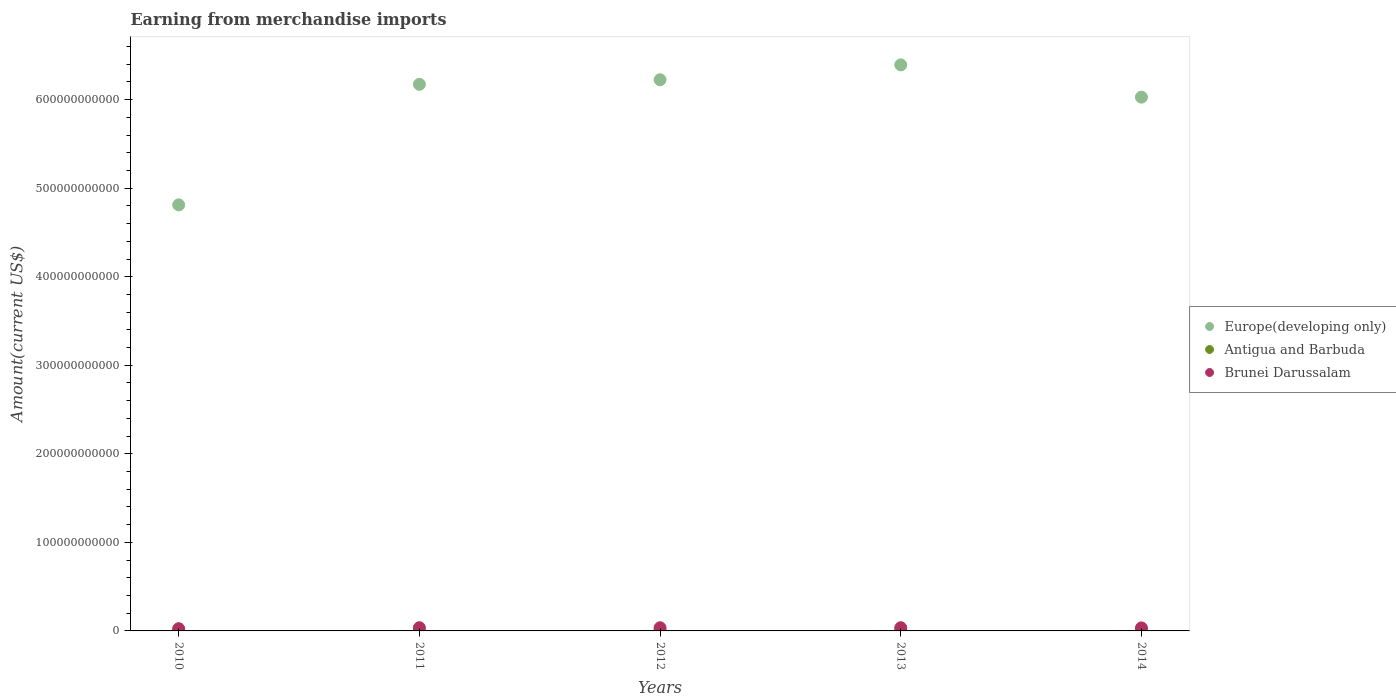Is the number of dotlines equal to the number of legend labels?
Provide a succinct answer. Yes. What is the amount earned from merchandise imports in Europe(developing only) in 2011?
Offer a terse response. 6.17e+11. Across all years, what is the maximum amount earned from merchandise imports in Europe(developing only)?
Offer a terse response. 6.39e+11. Across all years, what is the minimum amount earned from merchandise imports in Antigua and Barbuda?
Offer a terse response. 4.30e+08. In which year was the amount earned from merchandise imports in Antigua and Barbuda minimum?
Your answer should be very brief. 2011. What is the total amount earned from merchandise imports in Europe(developing only) in the graph?
Offer a terse response. 2.96e+12. What is the difference between the amount earned from merchandise imports in Antigua and Barbuda in 2010 and that in 2014?
Give a very brief answer. -1.13e+07. What is the difference between the amount earned from merchandise imports in Antigua and Barbuda in 2014 and the amount earned from merchandise imports in Europe(developing only) in 2010?
Provide a succinct answer. -4.81e+11. What is the average amount earned from merchandise imports in Europe(developing only) per year?
Your answer should be compact. 5.93e+11. In the year 2013, what is the difference between the amount earned from merchandise imports in Antigua and Barbuda and amount earned from merchandise imports in Brunei Darussalam?
Offer a terse response. -3.11e+09. In how many years, is the amount earned from merchandise imports in Antigua and Barbuda greater than 600000000000 US$?
Your answer should be very brief. 0. What is the ratio of the amount earned from merchandise imports in Europe(developing only) in 2011 to that in 2012?
Your answer should be very brief. 0.99. Is the difference between the amount earned from merchandise imports in Antigua and Barbuda in 2012 and 2014 greater than the difference between the amount earned from merchandise imports in Brunei Darussalam in 2012 and 2014?
Give a very brief answer. No. What is the difference between the highest and the second highest amount earned from merchandise imports in Europe(developing only)?
Offer a terse response. 1.68e+1. What is the difference between the highest and the lowest amount earned from merchandise imports in Europe(developing only)?
Keep it short and to the point. 1.58e+11. In how many years, is the amount earned from merchandise imports in Antigua and Barbuda greater than the average amount earned from merchandise imports in Antigua and Barbuda taken over all years?
Ensure brevity in your answer.  4. Is the sum of the amount earned from merchandise imports in Europe(developing only) in 2010 and 2012 greater than the maximum amount earned from merchandise imports in Antigua and Barbuda across all years?
Provide a short and direct response. Yes. Is it the case that in every year, the sum of the amount earned from merchandise imports in Europe(developing only) and amount earned from merchandise imports in Brunei Darussalam  is greater than the amount earned from merchandise imports in Antigua and Barbuda?
Keep it short and to the point. Yes. Is the amount earned from merchandise imports in Brunei Darussalam strictly less than the amount earned from merchandise imports in Europe(developing only) over the years?
Keep it short and to the point. Yes. How many dotlines are there?
Keep it short and to the point. 3. How many years are there in the graph?
Provide a short and direct response. 5. What is the difference between two consecutive major ticks on the Y-axis?
Give a very brief answer. 1.00e+11. Are the values on the major ticks of Y-axis written in scientific E-notation?
Your answer should be compact. No. Where does the legend appear in the graph?
Offer a terse response. Center right. How are the legend labels stacked?
Keep it short and to the point. Vertical. What is the title of the graph?
Make the answer very short. Earning from merchandise imports. Does "Mauritius" appear as one of the legend labels in the graph?
Ensure brevity in your answer.  No. What is the label or title of the X-axis?
Your answer should be very brief. Years. What is the label or title of the Y-axis?
Offer a very short reply. Amount(current US$). What is the Amount(current US$) of Europe(developing only) in 2010?
Offer a terse response. 4.81e+11. What is the Amount(current US$) of Antigua and Barbuda in 2010?
Offer a terse response. 5.01e+08. What is the Amount(current US$) in Brunei Darussalam in 2010?
Provide a short and direct response. 2.54e+09. What is the Amount(current US$) in Europe(developing only) in 2011?
Provide a succinct answer. 6.17e+11. What is the Amount(current US$) of Antigua and Barbuda in 2011?
Provide a short and direct response. 4.30e+08. What is the Amount(current US$) in Brunei Darussalam in 2011?
Provide a succinct answer. 3.63e+09. What is the Amount(current US$) in Europe(developing only) in 2012?
Provide a succinct answer. 6.22e+11. What is the Amount(current US$) of Antigua and Barbuda in 2012?
Your answer should be very brief. 4.92e+08. What is the Amount(current US$) of Brunei Darussalam in 2012?
Provide a succinct answer. 3.57e+09. What is the Amount(current US$) of Europe(developing only) in 2013?
Provide a short and direct response. 6.39e+11. What is the Amount(current US$) in Antigua and Barbuda in 2013?
Make the answer very short. 5.03e+08. What is the Amount(current US$) in Brunei Darussalam in 2013?
Your answer should be compact. 3.61e+09. What is the Amount(current US$) of Europe(developing only) in 2014?
Ensure brevity in your answer.  6.03e+11. What is the Amount(current US$) of Antigua and Barbuda in 2014?
Your response must be concise. 5.13e+08. What is the Amount(current US$) of Brunei Darussalam in 2014?
Keep it short and to the point. 3.40e+09. Across all years, what is the maximum Amount(current US$) in Europe(developing only)?
Ensure brevity in your answer.  6.39e+11. Across all years, what is the maximum Amount(current US$) in Antigua and Barbuda?
Give a very brief answer. 5.13e+08. Across all years, what is the maximum Amount(current US$) of Brunei Darussalam?
Your answer should be compact. 3.63e+09. Across all years, what is the minimum Amount(current US$) of Europe(developing only)?
Offer a very short reply. 4.81e+11. Across all years, what is the minimum Amount(current US$) in Antigua and Barbuda?
Your response must be concise. 4.30e+08. Across all years, what is the minimum Amount(current US$) in Brunei Darussalam?
Offer a terse response. 2.54e+09. What is the total Amount(current US$) in Europe(developing only) in the graph?
Offer a terse response. 2.96e+12. What is the total Amount(current US$) of Antigua and Barbuda in the graph?
Your answer should be compact. 2.44e+09. What is the total Amount(current US$) in Brunei Darussalam in the graph?
Your answer should be compact. 1.68e+1. What is the difference between the Amount(current US$) of Europe(developing only) in 2010 and that in 2011?
Provide a short and direct response. -1.36e+11. What is the difference between the Amount(current US$) of Antigua and Barbuda in 2010 and that in 2011?
Provide a succinct answer. 7.08e+07. What is the difference between the Amount(current US$) in Brunei Darussalam in 2010 and that in 2011?
Make the answer very short. -1.09e+09. What is the difference between the Amount(current US$) of Europe(developing only) in 2010 and that in 2012?
Provide a succinct answer. -1.41e+11. What is the difference between the Amount(current US$) in Antigua and Barbuda in 2010 and that in 2012?
Give a very brief answer. 8.88e+06. What is the difference between the Amount(current US$) of Brunei Darussalam in 2010 and that in 2012?
Keep it short and to the point. -1.03e+09. What is the difference between the Amount(current US$) of Europe(developing only) in 2010 and that in 2013?
Your answer should be very brief. -1.58e+11. What is the difference between the Amount(current US$) of Antigua and Barbuda in 2010 and that in 2013?
Give a very brief answer. -1.84e+06. What is the difference between the Amount(current US$) of Brunei Darussalam in 2010 and that in 2013?
Ensure brevity in your answer.  -1.07e+09. What is the difference between the Amount(current US$) in Europe(developing only) in 2010 and that in 2014?
Provide a succinct answer. -1.22e+11. What is the difference between the Amount(current US$) of Antigua and Barbuda in 2010 and that in 2014?
Give a very brief answer. -1.13e+07. What is the difference between the Amount(current US$) of Brunei Darussalam in 2010 and that in 2014?
Your answer should be very brief. -8.62e+08. What is the difference between the Amount(current US$) in Europe(developing only) in 2011 and that in 2012?
Offer a terse response. -5.18e+09. What is the difference between the Amount(current US$) of Antigua and Barbuda in 2011 and that in 2012?
Provide a short and direct response. -6.19e+07. What is the difference between the Amount(current US$) of Brunei Darussalam in 2011 and that in 2012?
Give a very brief answer. 5.65e+07. What is the difference between the Amount(current US$) in Europe(developing only) in 2011 and that in 2013?
Offer a terse response. -2.20e+1. What is the difference between the Amount(current US$) of Antigua and Barbuda in 2011 and that in 2013?
Make the answer very short. -7.26e+07. What is the difference between the Amount(current US$) in Brunei Darussalam in 2011 and that in 2013?
Your answer should be very brief. 1.69e+07. What is the difference between the Amount(current US$) in Europe(developing only) in 2011 and that in 2014?
Your answer should be compact. 1.45e+1. What is the difference between the Amount(current US$) of Antigua and Barbuda in 2011 and that in 2014?
Offer a very short reply. -8.21e+07. What is the difference between the Amount(current US$) in Brunei Darussalam in 2011 and that in 2014?
Make the answer very short. 2.29e+08. What is the difference between the Amount(current US$) in Europe(developing only) in 2012 and that in 2013?
Give a very brief answer. -1.68e+1. What is the difference between the Amount(current US$) in Antigua and Barbuda in 2012 and that in 2013?
Offer a terse response. -1.07e+07. What is the difference between the Amount(current US$) in Brunei Darussalam in 2012 and that in 2013?
Provide a succinct answer. -3.96e+07. What is the difference between the Amount(current US$) in Europe(developing only) in 2012 and that in 2014?
Offer a terse response. 1.96e+1. What is the difference between the Amount(current US$) of Antigua and Barbuda in 2012 and that in 2014?
Offer a terse response. -2.02e+07. What is the difference between the Amount(current US$) in Brunei Darussalam in 2012 and that in 2014?
Offer a very short reply. 1.72e+08. What is the difference between the Amount(current US$) in Europe(developing only) in 2013 and that in 2014?
Offer a very short reply. 3.65e+1. What is the difference between the Amount(current US$) in Antigua and Barbuda in 2013 and that in 2014?
Make the answer very short. -9.48e+06. What is the difference between the Amount(current US$) in Brunei Darussalam in 2013 and that in 2014?
Your response must be concise. 2.12e+08. What is the difference between the Amount(current US$) in Europe(developing only) in 2010 and the Amount(current US$) in Antigua and Barbuda in 2011?
Provide a short and direct response. 4.81e+11. What is the difference between the Amount(current US$) of Europe(developing only) in 2010 and the Amount(current US$) of Brunei Darussalam in 2011?
Provide a succinct answer. 4.78e+11. What is the difference between the Amount(current US$) in Antigua and Barbuda in 2010 and the Amount(current US$) in Brunei Darussalam in 2011?
Provide a succinct answer. -3.13e+09. What is the difference between the Amount(current US$) in Europe(developing only) in 2010 and the Amount(current US$) in Antigua and Barbuda in 2012?
Offer a very short reply. 4.81e+11. What is the difference between the Amount(current US$) of Europe(developing only) in 2010 and the Amount(current US$) of Brunei Darussalam in 2012?
Give a very brief answer. 4.78e+11. What is the difference between the Amount(current US$) of Antigua and Barbuda in 2010 and the Amount(current US$) of Brunei Darussalam in 2012?
Make the answer very short. -3.07e+09. What is the difference between the Amount(current US$) of Europe(developing only) in 2010 and the Amount(current US$) of Antigua and Barbuda in 2013?
Give a very brief answer. 4.81e+11. What is the difference between the Amount(current US$) of Europe(developing only) in 2010 and the Amount(current US$) of Brunei Darussalam in 2013?
Ensure brevity in your answer.  4.78e+11. What is the difference between the Amount(current US$) in Antigua and Barbuda in 2010 and the Amount(current US$) in Brunei Darussalam in 2013?
Your answer should be compact. -3.11e+09. What is the difference between the Amount(current US$) of Europe(developing only) in 2010 and the Amount(current US$) of Antigua and Barbuda in 2014?
Your answer should be very brief. 4.81e+11. What is the difference between the Amount(current US$) of Europe(developing only) in 2010 and the Amount(current US$) of Brunei Darussalam in 2014?
Provide a short and direct response. 4.78e+11. What is the difference between the Amount(current US$) in Antigua and Barbuda in 2010 and the Amount(current US$) in Brunei Darussalam in 2014?
Offer a very short reply. -2.90e+09. What is the difference between the Amount(current US$) of Europe(developing only) in 2011 and the Amount(current US$) of Antigua and Barbuda in 2012?
Offer a terse response. 6.17e+11. What is the difference between the Amount(current US$) of Europe(developing only) in 2011 and the Amount(current US$) of Brunei Darussalam in 2012?
Offer a very short reply. 6.14e+11. What is the difference between the Amount(current US$) in Antigua and Barbuda in 2011 and the Amount(current US$) in Brunei Darussalam in 2012?
Keep it short and to the point. -3.14e+09. What is the difference between the Amount(current US$) in Europe(developing only) in 2011 and the Amount(current US$) in Antigua and Barbuda in 2013?
Ensure brevity in your answer.  6.17e+11. What is the difference between the Amount(current US$) of Europe(developing only) in 2011 and the Amount(current US$) of Brunei Darussalam in 2013?
Your answer should be very brief. 6.14e+11. What is the difference between the Amount(current US$) of Antigua and Barbuda in 2011 and the Amount(current US$) of Brunei Darussalam in 2013?
Provide a short and direct response. -3.18e+09. What is the difference between the Amount(current US$) of Europe(developing only) in 2011 and the Amount(current US$) of Antigua and Barbuda in 2014?
Keep it short and to the point. 6.17e+11. What is the difference between the Amount(current US$) in Europe(developing only) in 2011 and the Amount(current US$) in Brunei Darussalam in 2014?
Keep it short and to the point. 6.14e+11. What is the difference between the Amount(current US$) of Antigua and Barbuda in 2011 and the Amount(current US$) of Brunei Darussalam in 2014?
Keep it short and to the point. -2.97e+09. What is the difference between the Amount(current US$) of Europe(developing only) in 2012 and the Amount(current US$) of Antigua and Barbuda in 2013?
Provide a succinct answer. 6.22e+11. What is the difference between the Amount(current US$) of Europe(developing only) in 2012 and the Amount(current US$) of Brunei Darussalam in 2013?
Make the answer very short. 6.19e+11. What is the difference between the Amount(current US$) of Antigua and Barbuda in 2012 and the Amount(current US$) of Brunei Darussalam in 2013?
Offer a terse response. -3.12e+09. What is the difference between the Amount(current US$) of Europe(developing only) in 2012 and the Amount(current US$) of Antigua and Barbuda in 2014?
Your response must be concise. 6.22e+11. What is the difference between the Amount(current US$) in Europe(developing only) in 2012 and the Amount(current US$) in Brunei Darussalam in 2014?
Your answer should be very brief. 6.19e+11. What is the difference between the Amount(current US$) of Antigua and Barbuda in 2012 and the Amount(current US$) of Brunei Darussalam in 2014?
Ensure brevity in your answer.  -2.91e+09. What is the difference between the Amount(current US$) in Europe(developing only) in 2013 and the Amount(current US$) in Antigua and Barbuda in 2014?
Ensure brevity in your answer.  6.39e+11. What is the difference between the Amount(current US$) in Europe(developing only) in 2013 and the Amount(current US$) in Brunei Darussalam in 2014?
Your answer should be very brief. 6.36e+11. What is the difference between the Amount(current US$) in Antigua and Barbuda in 2013 and the Amount(current US$) in Brunei Darussalam in 2014?
Offer a terse response. -2.90e+09. What is the average Amount(current US$) of Europe(developing only) per year?
Give a very brief answer. 5.93e+11. What is the average Amount(current US$) of Antigua and Barbuda per year?
Provide a succinct answer. 4.88e+08. What is the average Amount(current US$) of Brunei Darussalam per year?
Ensure brevity in your answer.  3.35e+09. In the year 2010, what is the difference between the Amount(current US$) in Europe(developing only) and Amount(current US$) in Antigua and Barbuda?
Provide a short and direct response. 4.81e+11. In the year 2010, what is the difference between the Amount(current US$) of Europe(developing only) and Amount(current US$) of Brunei Darussalam?
Offer a terse response. 4.79e+11. In the year 2010, what is the difference between the Amount(current US$) in Antigua and Barbuda and Amount(current US$) in Brunei Darussalam?
Offer a very short reply. -2.04e+09. In the year 2011, what is the difference between the Amount(current US$) of Europe(developing only) and Amount(current US$) of Antigua and Barbuda?
Your response must be concise. 6.17e+11. In the year 2011, what is the difference between the Amount(current US$) of Europe(developing only) and Amount(current US$) of Brunei Darussalam?
Your response must be concise. 6.14e+11. In the year 2011, what is the difference between the Amount(current US$) in Antigua and Barbuda and Amount(current US$) in Brunei Darussalam?
Give a very brief answer. -3.20e+09. In the year 2012, what is the difference between the Amount(current US$) in Europe(developing only) and Amount(current US$) in Antigua and Barbuda?
Provide a short and direct response. 6.22e+11. In the year 2012, what is the difference between the Amount(current US$) of Europe(developing only) and Amount(current US$) of Brunei Darussalam?
Your answer should be compact. 6.19e+11. In the year 2012, what is the difference between the Amount(current US$) of Antigua and Barbuda and Amount(current US$) of Brunei Darussalam?
Offer a very short reply. -3.08e+09. In the year 2013, what is the difference between the Amount(current US$) in Europe(developing only) and Amount(current US$) in Antigua and Barbuda?
Your answer should be compact. 6.39e+11. In the year 2013, what is the difference between the Amount(current US$) of Europe(developing only) and Amount(current US$) of Brunei Darussalam?
Provide a succinct answer. 6.36e+11. In the year 2013, what is the difference between the Amount(current US$) in Antigua and Barbuda and Amount(current US$) in Brunei Darussalam?
Offer a very short reply. -3.11e+09. In the year 2014, what is the difference between the Amount(current US$) in Europe(developing only) and Amount(current US$) in Antigua and Barbuda?
Keep it short and to the point. 6.02e+11. In the year 2014, what is the difference between the Amount(current US$) of Europe(developing only) and Amount(current US$) of Brunei Darussalam?
Keep it short and to the point. 5.99e+11. In the year 2014, what is the difference between the Amount(current US$) of Antigua and Barbuda and Amount(current US$) of Brunei Darussalam?
Offer a very short reply. -2.89e+09. What is the ratio of the Amount(current US$) in Europe(developing only) in 2010 to that in 2011?
Provide a succinct answer. 0.78. What is the ratio of the Amount(current US$) of Antigua and Barbuda in 2010 to that in 2011?
Make the answer very short. 1.16. What is the ratio of the Amount(current US$) in Brunei Darussalam in 2010 to that in 2011?
Provide a succinct answer. 0.7. What is the ratio of the Amount(current US$) of Europe(developing only) in 2010 to that in 2012?
Ensure brevity in your answer.  0.77. What is the ratio of the Amount(current US$) of Antigua and Barbuda in 2010 to that in 2012?
Your response must be concise. 1.02. What is the ratio of the Amount(current US$) in Brunei Darussalam in 2010 to that in 2012?
Ensure brevity in your answer.  0.71. What is the ratio of the Amount(current US$) in Europe(developing only) in 2010 to that in 2013?
Offer a very short reply. 0.75. What is the ratio of the Amount(current US$) in Antigua and Barbuda in 2010 to that in 2013?
Keep it short and to the point. 1. What is the ratio of the Amount(current US$) in Brunei Darussalam in 2010 to that in 2013?
Offer a very short reply. 0.7. What is the ratio of the Amount(current US$) in Europe(developing only) in 2010 to that in 2014?
Provide a short and direct response. 0.8. What is the ratio of the Amount(current US$) of Antigua and Barbuda in 2010 to that in 2014?
Your answer should be compact. 0.98. What is the ratio of the Amount(current US$) in Brunei Darussalam in 2010 to that in 2014?
Provide a short and direct response. 0.75. What is the ratio of the Amount(current US$) in Europe(developing only) in 2011 to that in 2012?
Your response must be concise. 0.99. What is the ratio of the Amount(current US$) of Antigua and Barbuda in 2011 to that in 2012?
Offer a very short reply. 0.87. What is the ratio of the Amount(current US$) of Brunei Darussalam in 2011 to that in 2012?
Provide a short and direct response. 1.02. What is the ratio of the Amount(current US$) in Europe(developing only) in 2011 to that in 2013?
Ensure brevity in your answer.  0.97. What is the ratio of the Amount(current US$) in Antigua and Barbuda in 2011 to that in 2013?
Provide a succinct answer. 0.86. What is the ratio of the Amount(current US$) in Brunei Darussalam in 2011 to that in 2013?
Your response must be concise. 1. What is the ratio of the Amount(current US$) of Europe(developing only) in 2011 to that in 2014?
Ensure brevity in your answer.  1.02. What is the ratio of the Amount(current US$) of Antigua and Barbuda in 2011 to that in 2014?
Provide a short and direct response. 0.84. What is the ratio of the Amount(current US$) of Brunei Darussalam in 2011 to that in 2014?
Make the answer very short. 1.07. What is the ratio of the Amount(current US$) in Europe(developing only) in 2012 to that in 2013?
Offer a very short reply. 0.97. What is the ratio of the Amount(current US$) of Antigua and Barbuda in 2012 to that in 2013?
Offer a terse response. 0.98. What is the ratio of the Amount(current US$) of Europe(developing only) in 2012 to that in 2014?
Give a very brief answer. 1.03. What is the ratio of the Amount(current US$) in Antigua and Barbuda in 2012 to that in 2014?
Give a very brief answer. 0.96. What is the ratio of the Amount(current US$) of Brunei Darussalam in 2012 to that in 2014?
Ensure brevity in your answer.  1.05. What is the ratio of the Amount(current US$) of Europe(developing only) in 2013 to that in 2014?
Keep it short and to the point. 1.06. What is the ratio of the Amount(current US$) in Antigua and Barbuda in 2013 to that in 2014?
Provide a succinct answer. 0.98. What is the ratio of the Amount(current US$) of Brunei Darussalam in 2013 to that in 2014?
Provide a succinct answer. 1.06. What is the difference between the highest and the second highest Amount(current US$) of Europe(developing only)?
Your answer should be very brief. 1.68e+1. What is the difference between the highest and the second highest Amount(current US$) in Antigua and Barbuda?
Give a very brief answer. 9.48e+06. What is the difference between the highest and the second highest Amount(current US$) in Brunei Darussalam?
Your answer should be compact. 1.69e+07. What is the difference between the highest and the lowest Amount(current US$) in Europe(developing only)?
Your response must be concise. 1.58e+11. What is the difference between the highest and the lowest Amount(current US$) of Antigua and Barbuda?
Your response must be concise. 8.21e+07. What is the difference between the highest and the lowest Amount(current US$) of Brunei Darussalam?
Keep it short and to the point. 1.09e+09. 